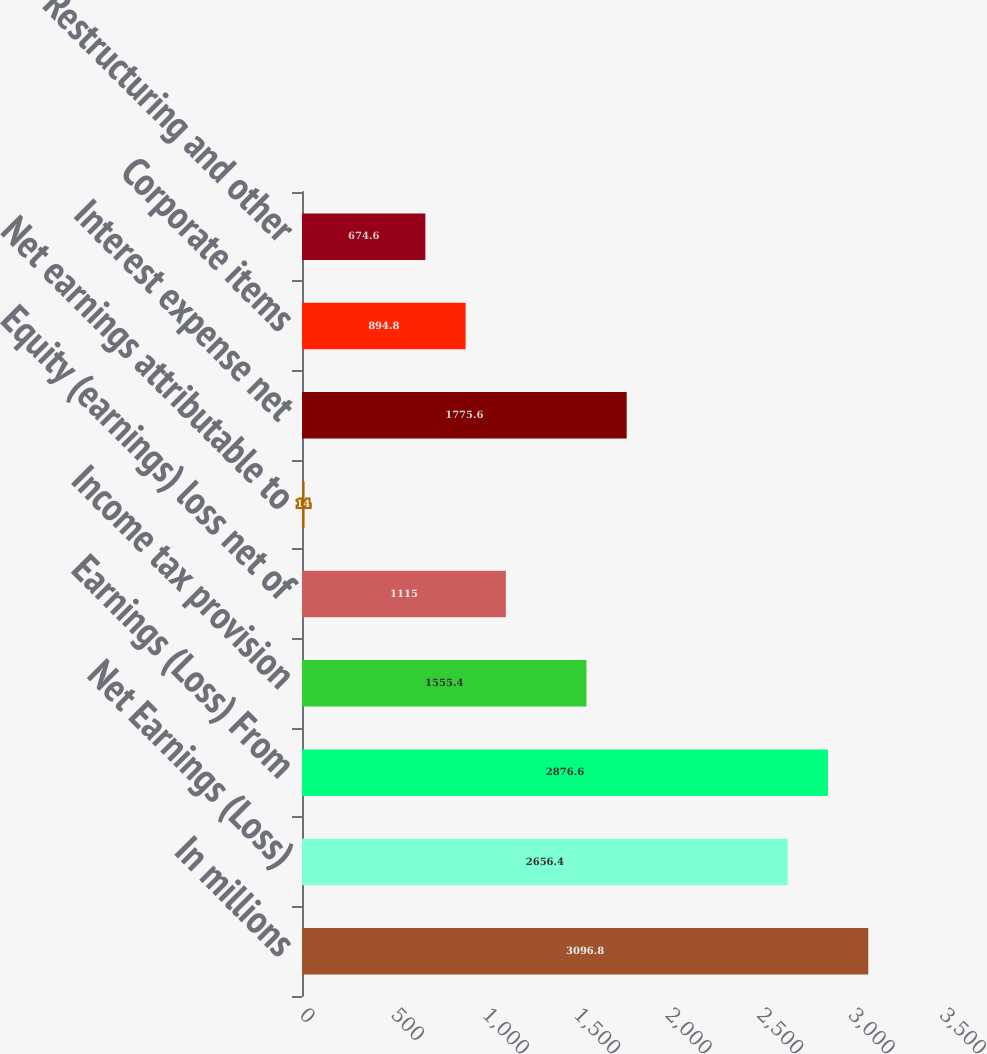Convert chart to OTSL. <chart><loc_0><loc_0><loc_500><loc_500><bar_chart><fcel>In millions<fcel>Net Earnings (Loss)<fcel>Earnings (Loss) From<fcel>Income tax provision<fcel>Equity (earnings) loss net of<fcel>Net earnings attributable to<fcel>Interest expense net<fcel>Corporate items<fcel>Restructuring and other<nl><fcel>3096.8<fcel>2656.4<fcel>2876.6<fcel>1555.4<fcel>1115<fcel>14<fcel>1775.6<fcel>894.8<fcel>674.6<nl></chart> 